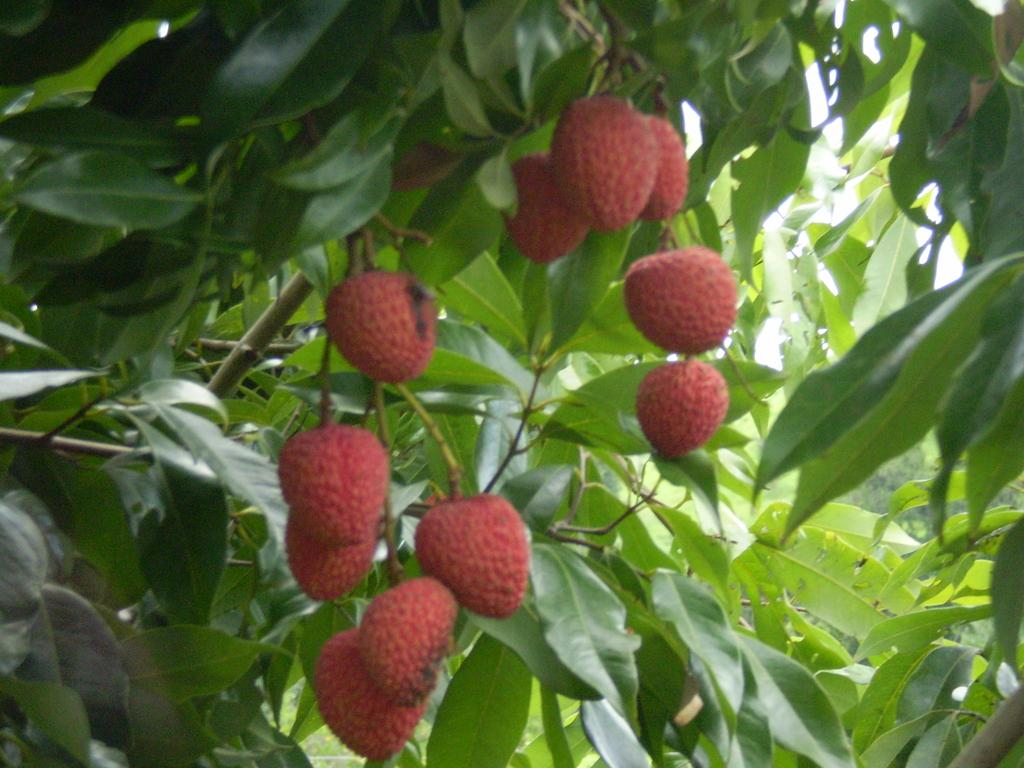What type of fruit is present in the image? There are strawberries in the image. Where are the strawberries located? The strawberries are on a plant. What type of punishment is being given to the strawberries in the image? There is no punishment being given to the strawberries in the image; they are simply growing on a plant. What type of jam is being made from the strawberries in the image? There is no jam-making process shown in the image; it only depicts strawberries on a plant. 